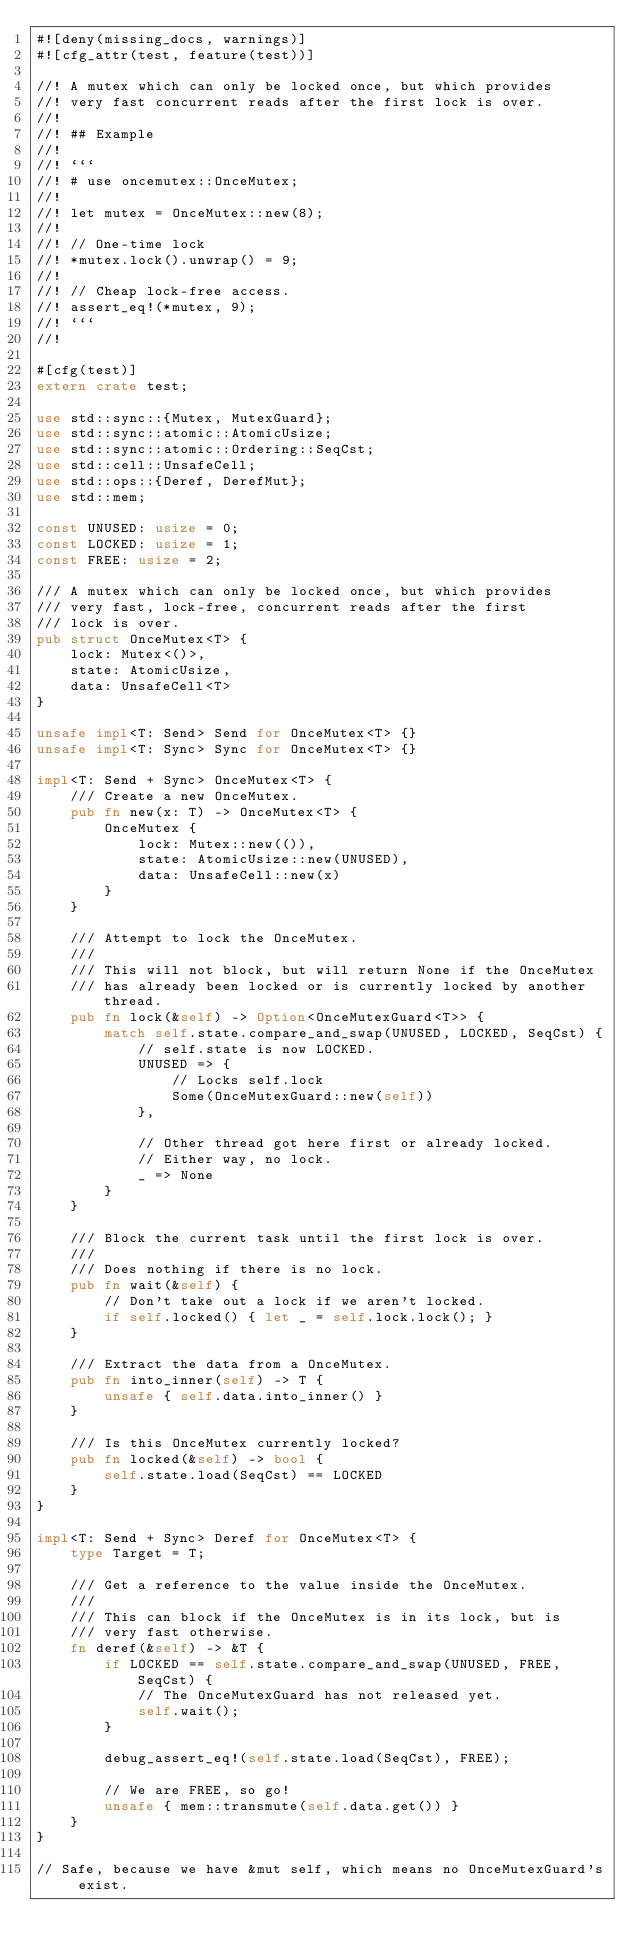<code> <loc_0><loc_0><loc_500><loc_500><_Rust_>#![deny(missing_docs, warnings)]
#![cfg_attr(test, feature(test))]

//! A mutex which can only be locked once, but which provides
//! very fast concurrent reads after the first lock is over.
//!
//! ## Example
//!
//! ```
//! # use oncemutex::OnceMutex;
//!
//! let mutex = OnceMutex::new(8);
//!
//! // One-time lock
//! *mutex.lock().unwrap() = 9;
//!
//! // Cheap lock-free access.
//! assert_eq!(*mutex, 9);
//! ```
//!

#[cfg(test)]
extern crate test;

use std::sync::{Mutex, MutexGuard};
use std::sync::atomic::AtomicUsize;
use std::sync::atomic::Ordering::SeqCst;
use std::cell::UnsafeCell;
use std::ops::{Deref, DerefMut};
use std::mem;

const UNUSED: usize = 0;
const LOCKED: usize = 1;
const FREE: usize = 2;

/// A mutex which can only be locked once, but which provides
/// very fast, lock-free, concurrent reads after the first
/// lock is over.
pub struct OnceMutex<T> {
    lock: Mutex<()>,
    state: AtomicUsize,
    data: UnsafeCell<T>
}

unsafe impl<T: Send> Send for OnceMutex<T> {}
unsafe impl<T: Sync> Sync for OnceMutex<T> {}

impl<T: Send + Sync> OnceMutex<T> {
    /// Create a new OnceMutex.
    pub fn new(x: T) -> OnceMutex<T> {
        OnceMutex {
            lock: Mutex::new(()),
            state: AtomicUsize::new(UNUSED),
            data: UnsafeCell::new(x)
        }
    }

    /// Attempt to lock the OnceMutex.
    ///
    /// This will not block, but will return None if the OnceMutex
    /// has already been locked or is currently locked by another thread.
    pub fn lock(&self) -> Option<OnceMutexGuard<T>> {
        match self.state.compare_and_swap(UNUSED, LOCKED, SeqCst) {
            // self.state is now LOCKED.
            UNUSED => {
                // Locks self.lock
                Some(OnceMutexGuard::new(self))
            },

            // Other thread got here first or already locked.
            // Either way, no lock.
            _ => None
        }
    }

    /// Block the current task until the first lock is over.
    ///
    /// Does nothing if there is no lock.
    pub fn wait(&self) {
        // Don't take out a lock if we aren't locked.
        if self.locked() { let _ = self.lock.lock(); }
    }

    /// Extract the data from a OnceMutex.
    pub fn into_inner(self) -> T {
        unsafe { self.data.into_inner() }
    }

    /// Is this OnceMutex currently locked?
    pub fn locked(&self) -> bool {
        self.state.load(SeqCst) == LOCKED
    }
}

impl<T: Send + Sync> Deref for OnceMutex<T> {
    type Target = T;

    /// Get a reference to the value inside the OnceMutex.
    ///
    /// This can block if the OnceMutex is in its lock, but is
    /// very fast otherwise.
    fn deref(&self) -> &T {
        if LOCKED == self.state.compare_and_swap(UNUSED, FREE, SeqCst) {
            // The OnceMutexGuard has not released yet.
            self.wait();
        }

        debug_assert_eq!(self.state.load(SeqCst), FREE);

        // We are FREE, so go!
        unsafe { mem::transmute(self.data.get()) }
    }
}

// Safe, because we have &mut self, which means no OnceMutexGuard's exist.</code> 